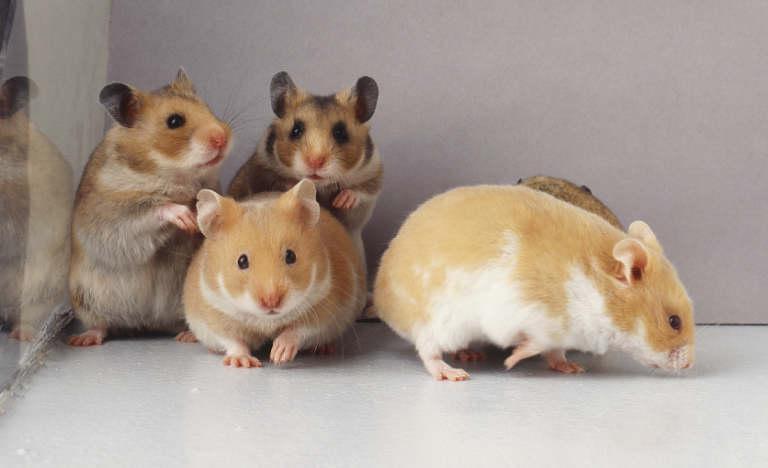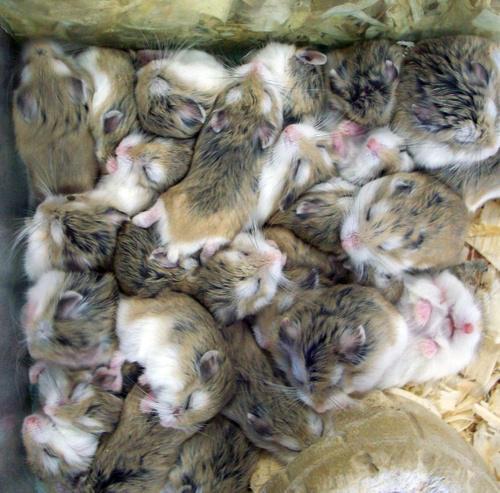The first image is the image on the left, the second image is the image on the right. For the images shown, is this caption "There are no more than five tan hamsters in the image on the left." true? Answer yes or no. Yes. 